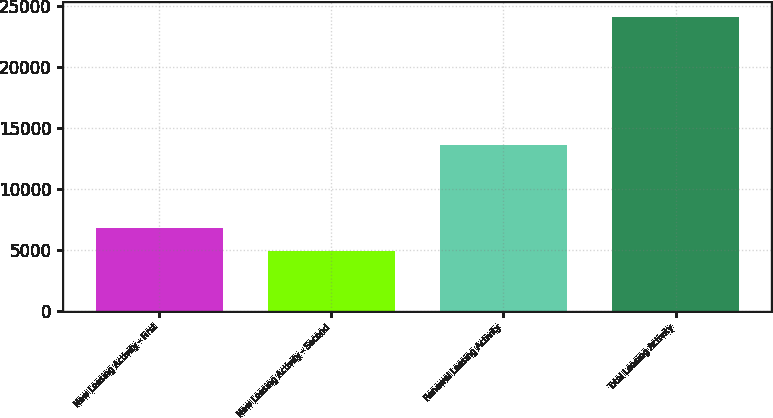Convert chart. <chart><loc_0><loc_0><loc_500><loc_500><bar_chart><fcel>New Leasing Activity - First<fcel>New Leasing Activity - Second<fcel>Renewal Leasing Activity<fcel>Total Leasing Activity<nl><fcel>6836.4<fcel>4911<fcel>13626<fcel>24165<nl></chart> 